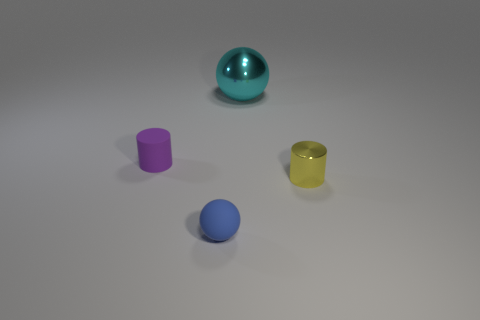How many other objects are there of the same color as the big shiny ball?
Your response must be concise. 0. Is the number of yellow metal cylinders behind the large shiny ball greater than the number of purple objects?
Your answer should be compact. No. There is a small matte thing behind the tiny yellow cylinder that is in front of the cylinder left of the yellow cylinder; what is its color?
Give a very brief answer. Purple. Does the cyan thing have the same material as the tiny yellow object?
Your response must be concise. Yes. Is there a blue object that has the same size as the purple thing?
Provide a short and direct response. Yes. There is a blue ball that is the same size as the yellow metallic cylinder; what is it made of?
Your answer should be compact. Rubber. Is the number of blue things the same as the number of small brown rubber cylinders?
Keep it short and to the point. No. Is there a tiny purple object of the same shape as the cyan metal thing?
Keep it short and to the point. No. What shape is the tiny thing that is to the right of the big cyan shiny ball?
Keep it short and to the point. Cylinder. What number of large cyan shiny cylinders are there?
Give a very brief answer. 0. 